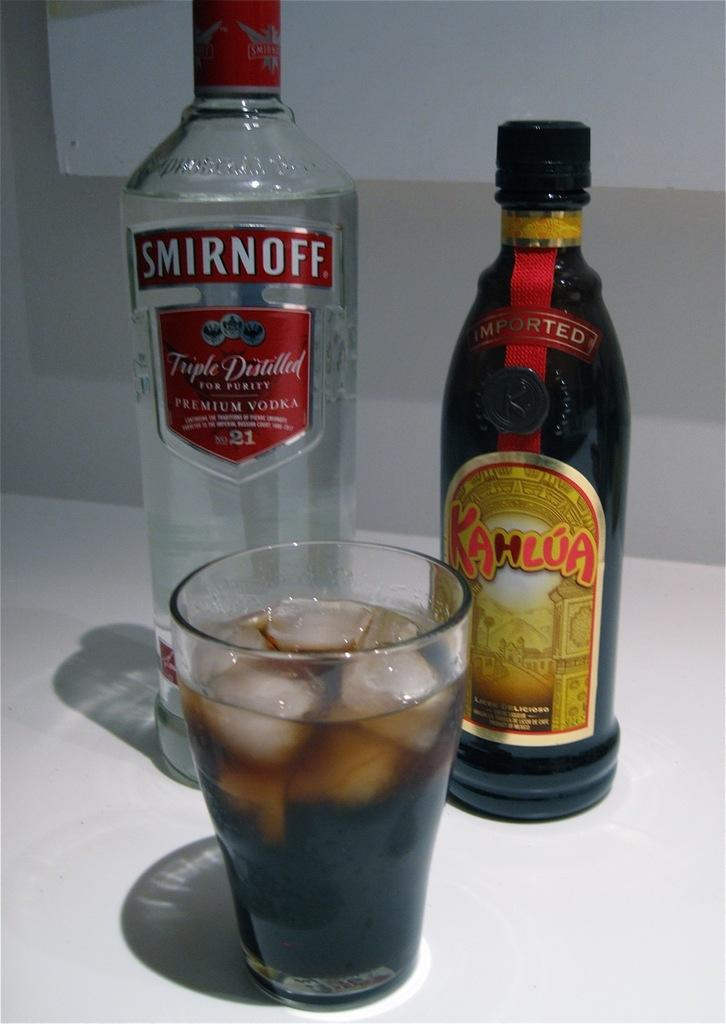Provide a one-sentence caption for the provided image. a bottle of smirnoff standing behind a glass of soda and ice. 